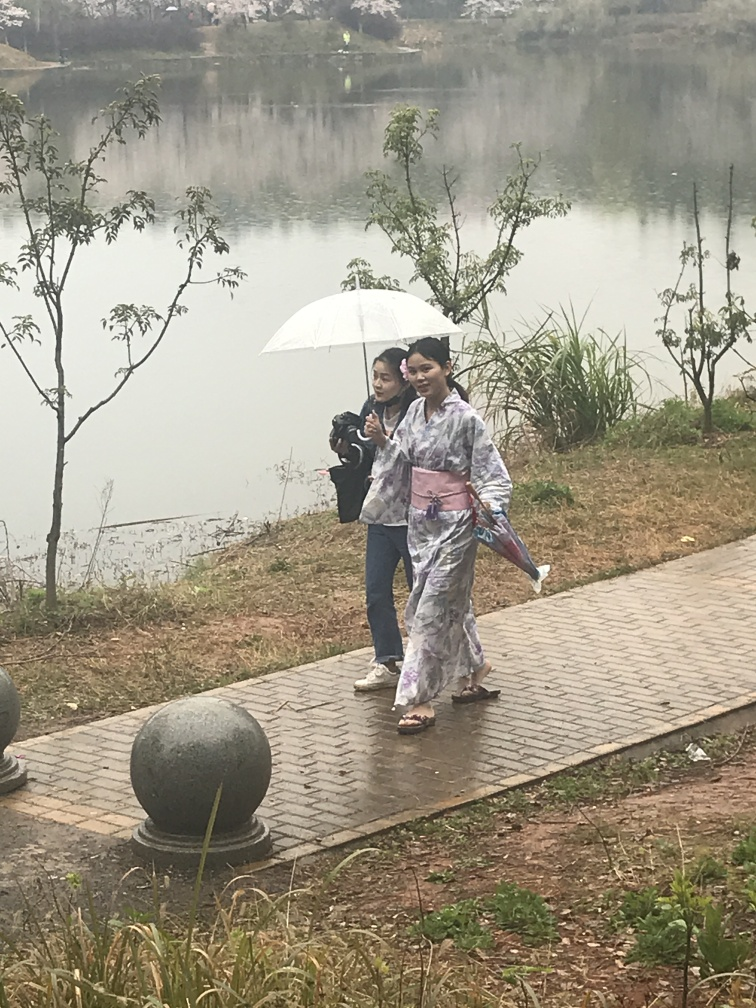What can you deduce about the weather and the setting in this image? Based on the presence of an umbrella and the attire of the individuals, it appears to be a cool or overcast day, potentially with some light rain or mist. The setting looks tranquil, with a lake or pond in the background, surrounded by greenery and partially obscured by fog, which suggests a natural, possibly rural location. 